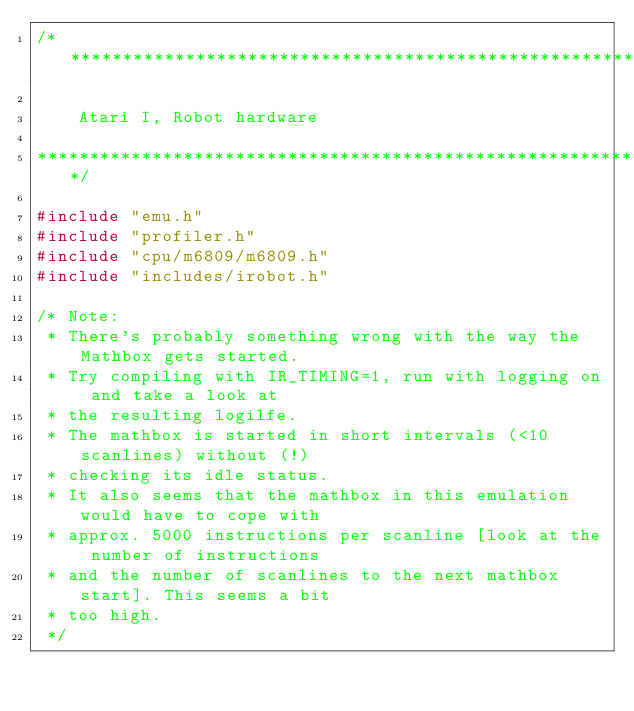<code> <loc_0><loc_0><loc_500><loc_500><_C_>/***************************************************************************

    Atari I, Robot hardware

***************************************************************************/

#include "emu.h"
#include "profiler.h"
#include "cpu/m6809/m6809.h"
#include "includes/irobot.h"

/* Note:
 * There's probably something wrong with the way the Mathbox gets started.
 * Try compiling with IR_TIMING=1, run with logging on and take a look at
 * the resulting logilfe.
 * The mathbox is started in short intervals (<10 scanlines) without (!)
 * checking its idle status.
 * It also seems that the mathbox in this emulation would have to cope with
 * approx. 5000 instructions per scanline [look at the number of instructions
 * and the number of scanlines to the next mathbox start]. This seems a bit
 * too high.
 */
</code> 